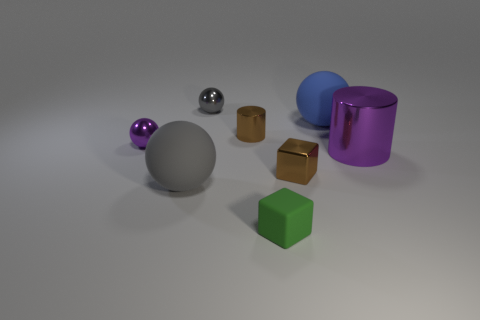Subtract all purple spheres. How many spheres are left? 3 Subtract all brown balls. Subtract all brown blocks. How many balls are left? 4 Add 2 red metallic objects. How many objects exist? 10 Subtract all cylinders. How many objects are left? 6 Add 3 small purple metal spheres. How many small purple metal spheres are left? 4 Add 3 gray metal balls. How many gray metal balls exist? 4 Subtract 0 blue blocks. How many objects are left? 8 Subtract all blue spheres. Subtract all brown objects. How many objects are left? 5 